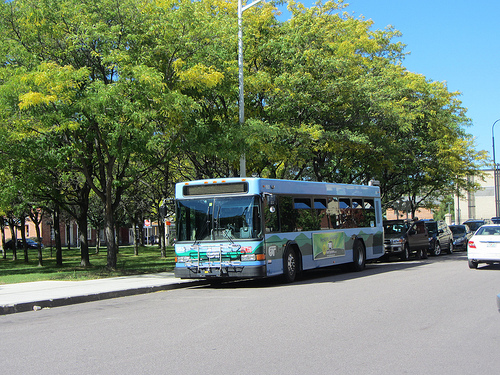On which side is the person? The person is on the right side of the image. 